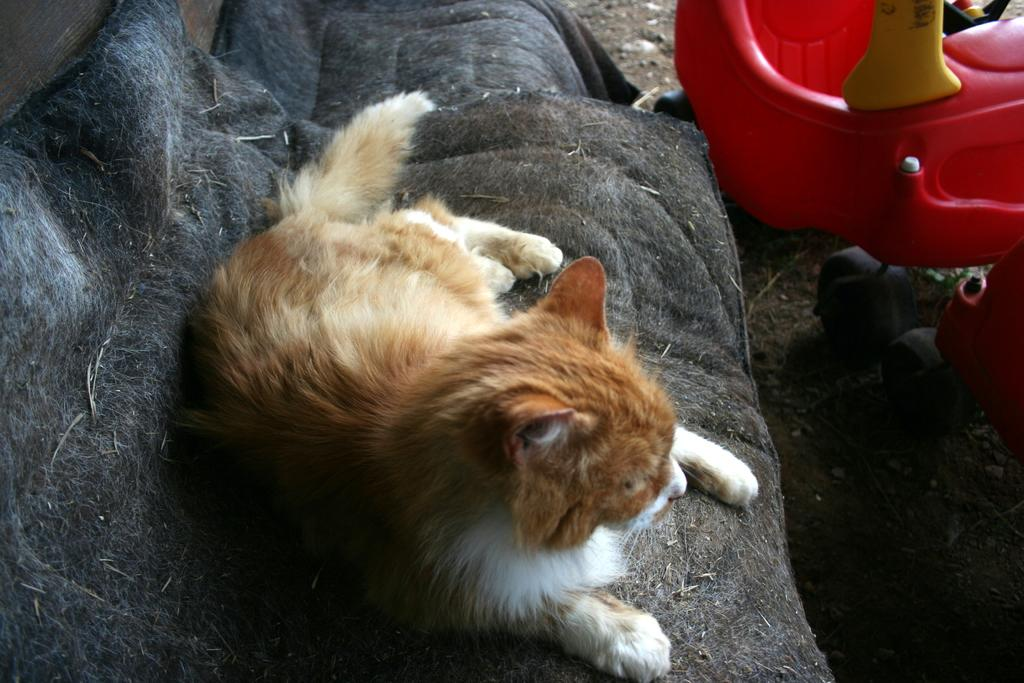What animal can be seen in the image? There is a cat in the image. Where is the cat located? The cat is on a sofa. What is the color of the cat? The cat is brown in color. What other furniture is visible in the image? There is a chair on the ground in the image. What sound does the cat make in the image? The image does not provide any information about the cat's sound, as it is a still image and not a video or audio recording. 